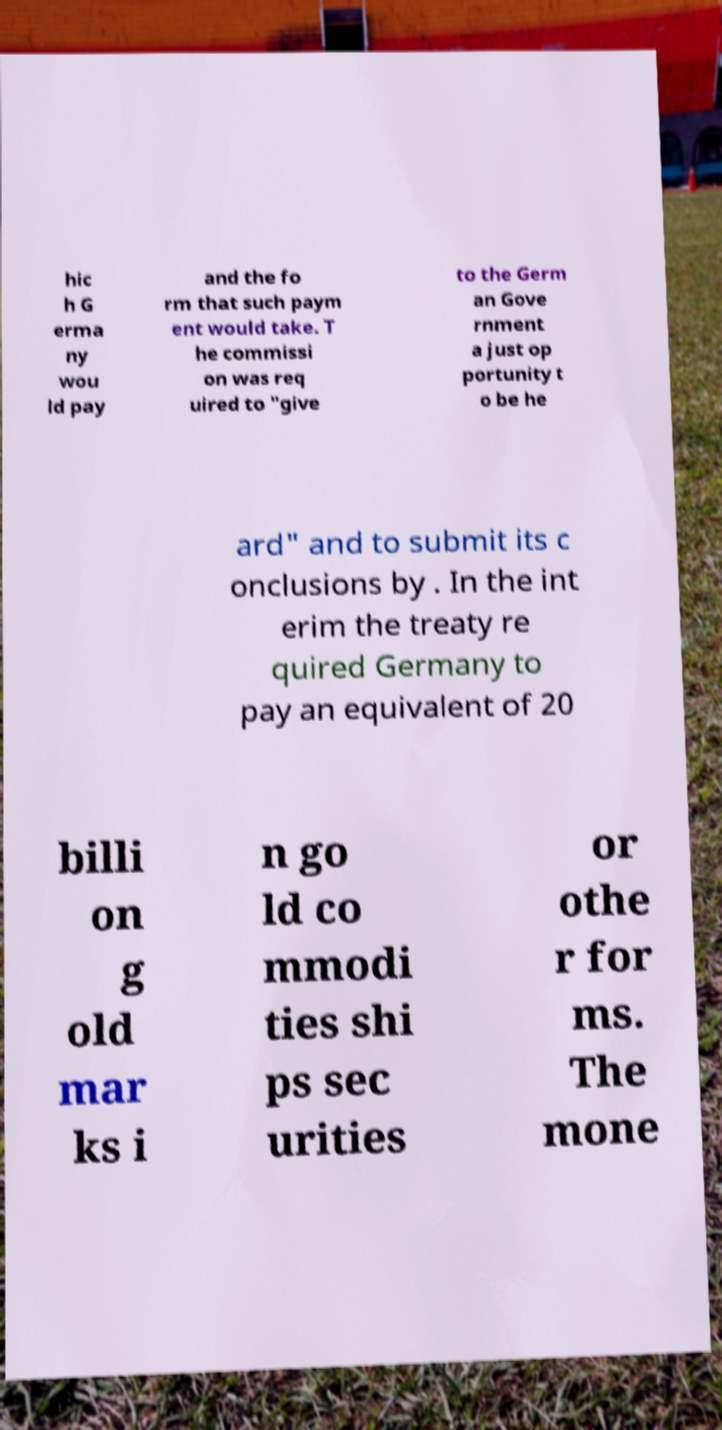Can you read and provide the text displayed in the image?This photo seems to have some interesting text. Can you extract and type it out for me? hic h G erma ny wou ld pay and the fo rm that such paym ent would take. T he commissi on was req uired to "give to the Germ an Gove rnment a just op portunity t o be he ard" and to submit its c onclusions by . In the int erim the treaty re quired Germany to pay an equivalent of 20 billi on g old mar ks i n go ld co mmodi ties shi ps sec urities or othe r for ms. The mone 